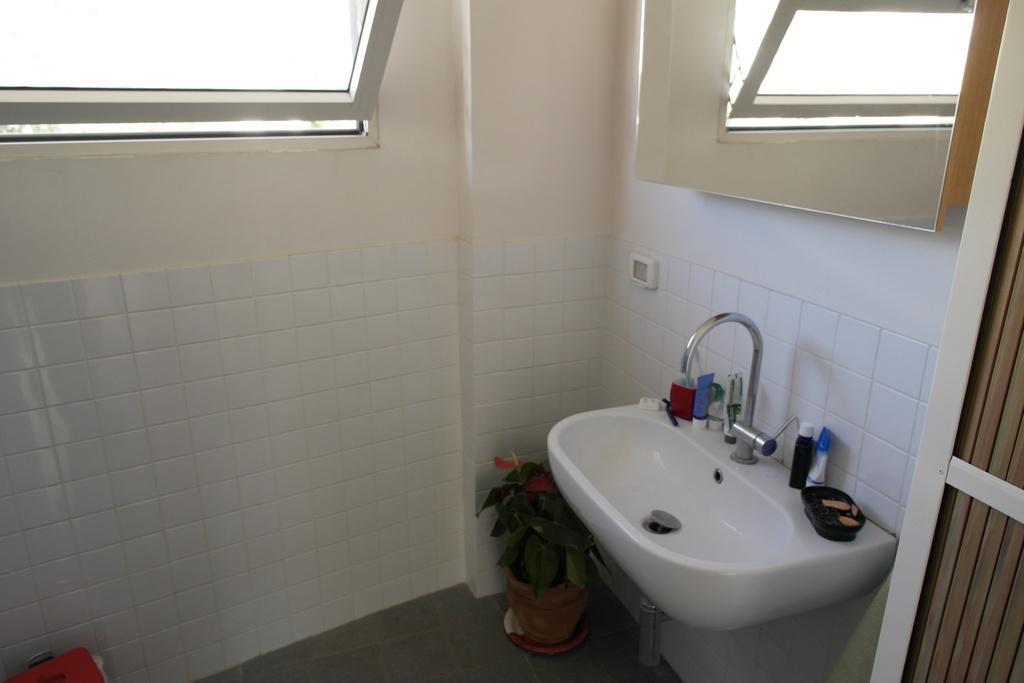Please provide a concise description of this image. In this image we can see potted plant, sink, tap, bottles, soap container, wall, mirror and window. It seems like there is a door on the right side of the image. 